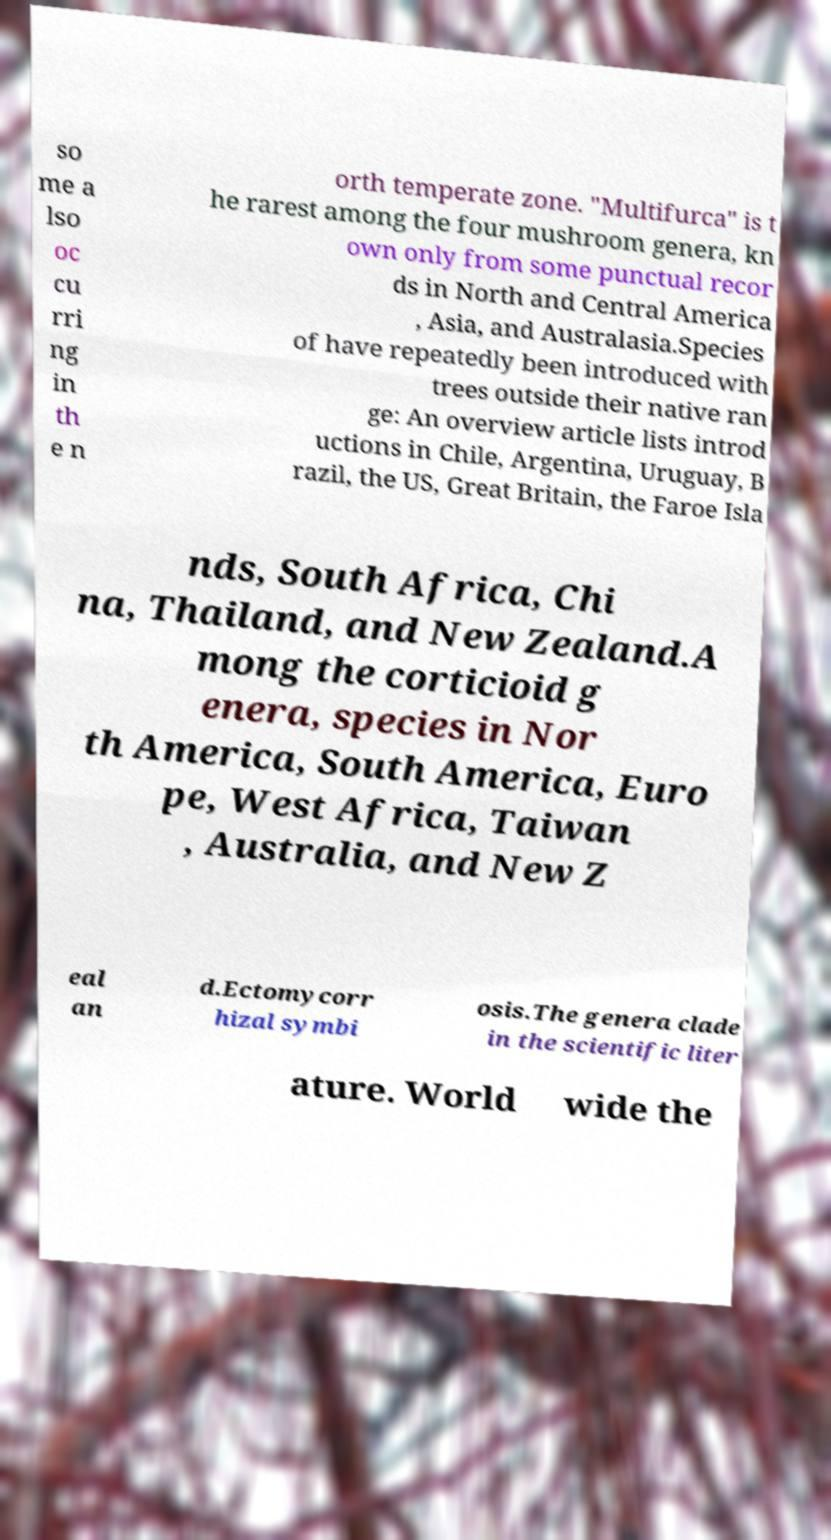What messages or text are displayed in this image? I need them in a readable, typed format. so me a lso oc cu rri ng in th e n orth temperate zone. "Multifurca" is t he rarest among the four mushroom genera, kn own only from some punctual recor ds in North and Central America , Asia, and Australasia.Species of have repeatedly been introduced with trees outside their native ran ge: An overview article lists introd uctions in Chile, Argentina, Uruguay, B razil, the US, Great Britain, the Faroe Isla nds, South Africa, Chi na, Thailand, and New Zealand.A mong the corticioid g enera, species in Nor th America, South America, Euro pe, West Africa, Taiwan , Australia, and New Z eal an d.Ectomycorr hizal symbi osis.The genera clade in the scientific liter ature. World wide the 